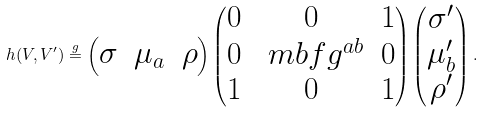Convert formula to latex. <formula><loc_0><loc_0><loc_500><loc_500>h ( V , V ^ { \prime } ) \overset { g } { = } \begin{pmatrix} \sigma & \mu _ { a } & \rho \end{pmatrix} \begin{pmatrix} 0 & 0 & 1 \\ 0 & \ m b f { g } ^ { a b } & 0 \\ 1 & 0 & 1 \\ \end{pmatrix} \begin{pmatrix} \sigma ^ { \prime } \\ \mu ^ { \prime } _ { b } \\ \rho ^ { \prime } \end{pmatrix} .</formula> 